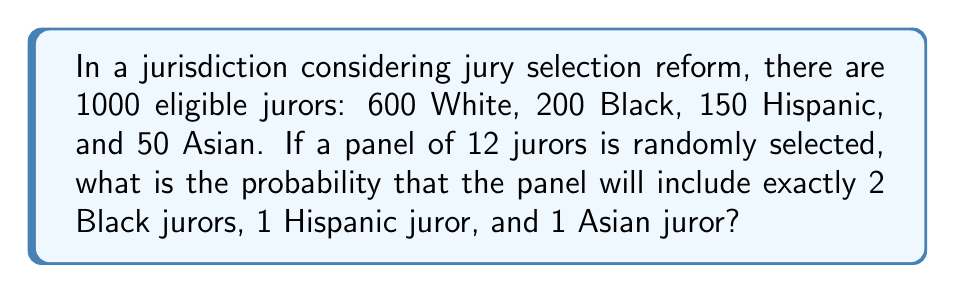Give your solution to this math problem. Let's approach this step-by-step using the concept of hypergeometric distribution:

1) First, we need to calculate the number of ways to select:
   - 2 Black jurors out of 200
   - 1 Hispanic juror out of 150
   - 1 Asian juror out of 50
   - 8 White jurors out of 600 (to make up the rest of the 12-person jury)

2) We can use the combination formula for each:

   $${200 \choose 2} \cdot {150 \choose 1} \cdot {50 \choose 1} \cdot {600 \choose 8}$$

3) Let's calculate each part:
   $${200 \choose 2} = 19900$$
   $${150 \choose 1} = 150$$
   $${50 \choose 1} = 50$$
   $${600 \choose 8} = 1.6007 \times 10^{17}$$

4) Multiplying these together:
   $$19900 \cdot 150 \cdot 50 \cdot 1.6007 \times 10^{17} = 2.3890 \times 10^{24}$$

5) Now, we need to divide this by the total number of ways to select 12 jurors out of 1000:
   $${1000 \choose 12} = 2.7921 \times 10^{26}$$

6) The probability is therefore:

   $$P = \frac{2.3890 \times 10^{24}}{2.7921 \times 10^{26}} = 0.0086$$
Answer: 0.0086 or 0.86% 